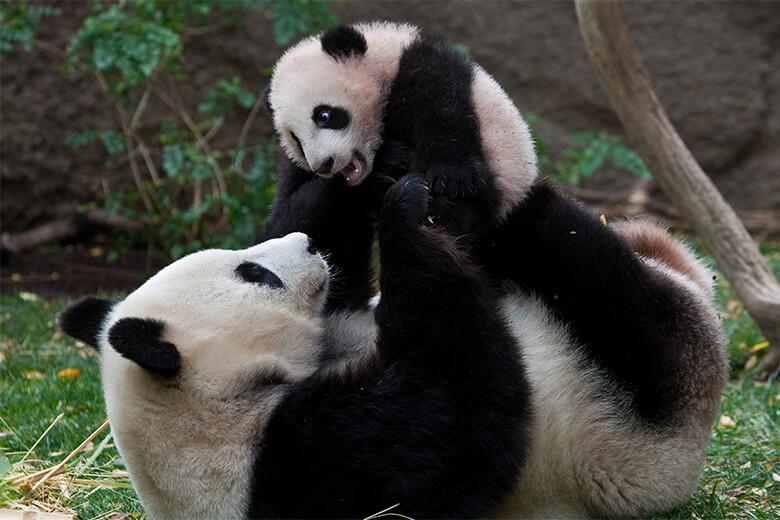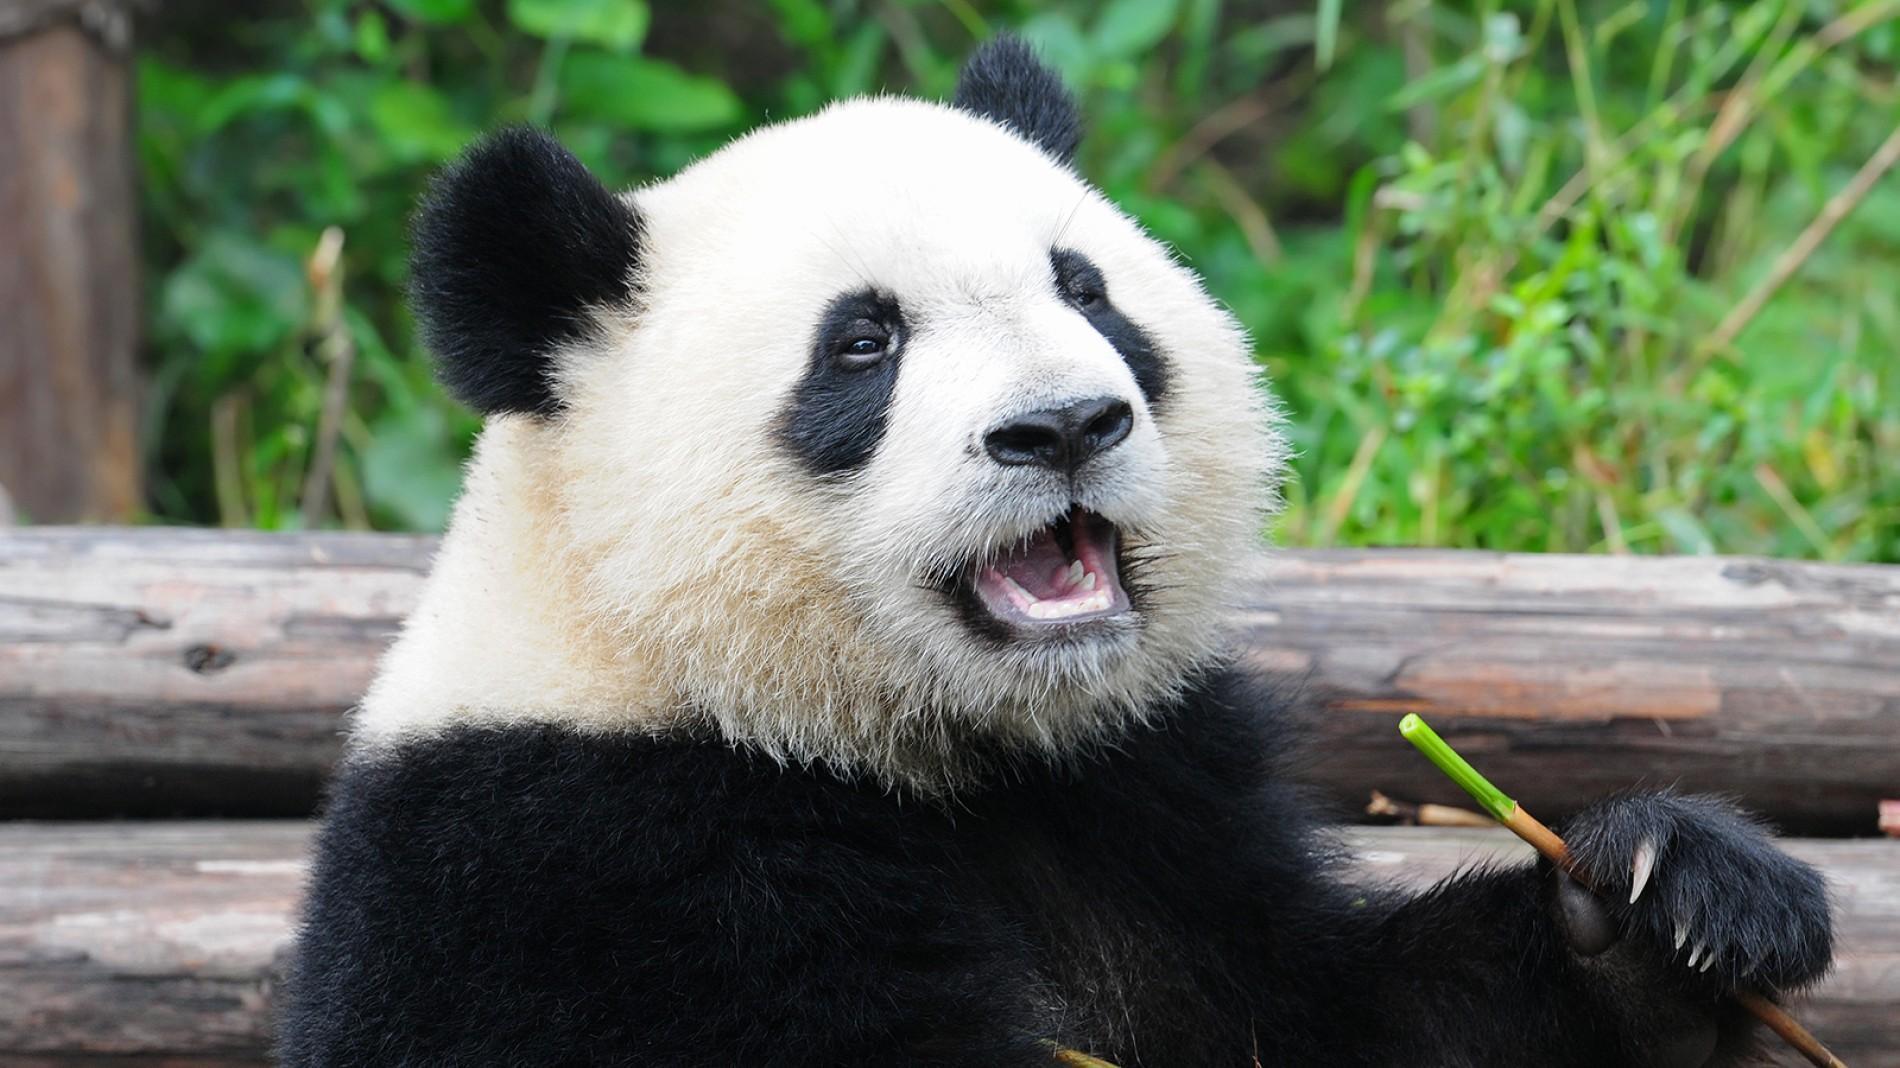The first image is the image on the left, the second image is the image on the right. For the images shown, is this caption "Two pandas are in a grassy area in the image on the left." true? Answer yes or no. Yes. The first image is the image on the left, the second image is the image on the right. Evaluate the accuracy of this statement regarding the images: "One image contains twice as many panda bears as the other image.". Is it true? Answer yes or no. Yes. 